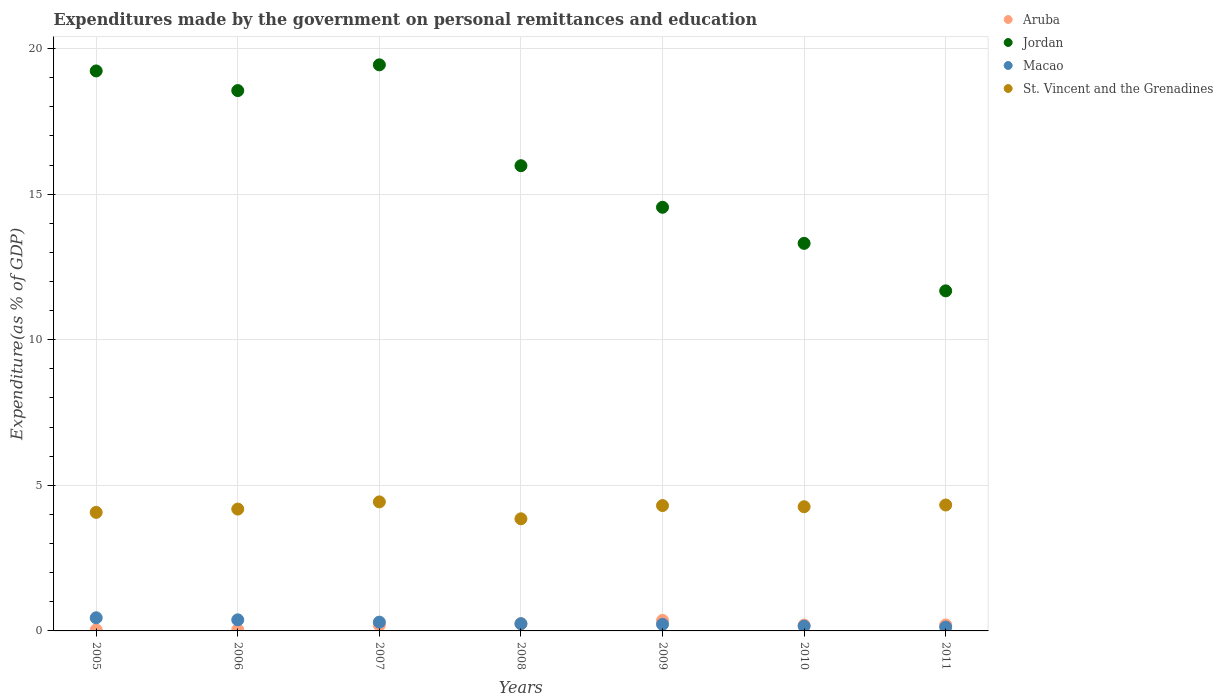How many different coloured dotlines are there?
Your response must be concise. 4. What is the expenditures made by the government on personal remittances and education in Jordan in 2009?
Ensure brevity in your answer.  14.55. Across all years, what is the maximum expenditures made by the government on personal remittances and education in St. Vincent and the Grenadines?
Provide a short and direct response. 4.43. Across all years, what is the minimum expenditures made by the government on personal remittances and education in Aruba?
Keep it short and to the point. 0.04. In which year was the expenditures made by the government on personal remittances and education in St. Vincent and the Grenadines minimum?
Offer a terse response. 2008. What is the total expenditures made by the government on personal remittances and education in Macao in the graph?
Make the answer very short. 1.91. What is the difference between the expenditures made by the government on personal remittances and education in St. Vincent and the Grenadines in 2007 and that in 2010?
Offer a terse response. 0.17. What is the difference between the expenditures made by the government on personal remittances and education in St. Vincent and the Grenadines in 2006 and the expenditures made by the government on personal remittances and education in Jordan in 2005?
Provide a succinct answer. -15.05. What is the average expenditures made by the government on personal remittances and education in Aruba per year?
Ensure brevity in your answer.  0.18. In the year 2009, what is the difference between the expenditures made by the government on personal remittances and education in Aruba and expenditures made by the government on personal remittances and education in Jordan?
Keep it short and to the point. -14.19. What is the ratio of the expenditures made by the government on personal remittances and education in Macao in 2007 to that in 2009?
Give a very brief answer. 1.33. Is the expenditures made by the government on personal remittances and education in Jordan in 2006 less than that in 2008?
Your response must be concise. No. What is the difference between the highest and the second highest expenditures made by the government on personal remittances and education in Macao?
Provide a short and direct response. 0.07. What is the difference between the highest and the lowest expenditures made by the government on personal remittances and education in Macao?
Your answer should be compact. 0.32. In how many years, is the expenditures made by the government on personal remittances and education in Macao greater than the average expenditures made by the government on personal remittances and education in Macao taken over all years?
Ensure brevity in your answer.  3. Is the sum of the expenditures made by the government on personal remittances and education in Jordan in 2005 and 2010 greater than the maximum expenditures made by the government on personal remittances and education in St. Vincent and the Grenadines across all years?
Your response must be concise. Yes. How many dotlines are there?
Ensure brevity in your answer.  4. How many years are there in the graph?
Offer a terse response. 7. Does the graph contain any zero values?
Ensure brevity in your answer.  No. Where does the legend appear in the graph?
Keep it short and to the point. Top right. How many legend labels are there?
Offer a terse response. 4. How are the legend labels stacked?
Your answer should be very brief. Vertical. What is the title of the graph?
Provide a succinct answer. Expenditures made by the government on personal remittances and education. What is the label or title of the Y-axis?
Give a very brief answer. Expenditure(as % of GDP). What is the Expenditure(as % of GDP) in Aruba in 2005?
Make the answer very short. 0.04. What is the Expenditure(as % of GDP) in Jordan in 2005?
Your answer should be very brief. 19.23. What is the Expenditure(as % of GDP) of Macao in 2005?
Your answer should be compact. 0.45. What is the Expenditure(as % of GDP) in St. Vincent and the Grenadines in 2005?
Give a very brief answer. 4.07. What is the Expenditure(as % of GDP) of Aruba in 2006?
Ensure brevity in your answer.  0.04. What is the Expenditure(as % of GDP) of Jordan in 2006?
Your response must be concise. 18.56. What is the Expenditure(as % of GDP) in Macao in 2006?
Offer a terse response. 0.38. What is the Expenditure(as % of GDP) of St. Vincent and the Grenadines in 2006?
Your answer should be very brief. 4.18. What is the Expenditure(as % of GDP) of Aruba in 2007?
Your answer should be compact. 0.2. What is the Expenditure(as % of GDP) in Jordan in 2007?
Ensure brevity in your answer.  19.44. What is the Expenditure(as % of GDP) of Macao in 2007?
Give a very brief answer. 0.3. What is the Expenditure(as % of GDP) of St. Vincent and the Grenadines in 2007?
Your response must be concise. 4.43. What is the Expenditure(as % of GDP) of Aruba in 2008?
Provide a short and direct response. 0.24. What is the Expenditure(as % of GDP) of Jordan in 2008?
Provide a succinct answer. 15.98. What is the Expenditure(as % of GDP) in Macao in 2008?
Your answer should be compact. 0.25. What is the Expenditure(as % of GDP) in St. Vincent and the Grenadines in 2008?
Offer a very short reply. 3.85. What is the Expenditure(as % of GDP) of Aruba in 2009?
Keep it short and to the point. 0.36. What is the Expenditure(as % of GDP) of Jordan in 2009?
Offer a very short reply. 14.55. What is the Expenditure(as % of GDP) of Macao in 2009?
Give a very brief answer. 0.23. What is the Expenditure(as % of GDP) of St. Vincent and the Grenadines in 2009?
Your answer should be compact. 4.31. What is the Expenditure(as % of GDP) in Aruba in 2010?
Your response must be concise. 0.2. What is the Expenditure(as % of GDP) of Jordan in 2010?
Your answer should be compact. 13.31. What is the Expenditure(as % of GDP) of Macao in 2010?
Your answer should be compact. 0.17. What is the Expenditure(as % of GDP) in St. Vincent and the Grenadines in 2010?
Make the answer very short. 4.27. What is the Expenditure(as % of GDP) in Aruba in 2011?
Your answer should be compact. 0.21. What is the Expenditure(as % of GDP) in Jordan in 2011?
Make the answer very short. 11.68. What is the Expenditure(as % of GDP) of Macao in 2011?
Your answer should be very brief. 0.13. What is the Expenditure(as % of GDP) of St. Vincent and the Grenadines in 2011?
Provide a succinct answer. 4.32. Across all years, what is the maximum Expenditure(as % of GDP) in Aruba?
Offer a very short reply. 0.36. Across all years, what is the maximum Expenditure(as % of GDP) of Jordan?
Your response must be concise. 19.44. Across all years, what is the maximum Expenditure(as % of GDP) of Macao?
Keep it short and to the point. 0.45. Across all years, what is the maximum Expenditure(as % of GDP) in St. Vincent and the Grenadines?
Your answer should be compact. 4.43. Across all years, what is the minimum Expenditure(as % of GDP) in Aruba?
Your response must be concise. 0.04. Across all years, what is the minimum Expenditure(as % of GDP) in Jordan?
Your response must be concise. 11.68. Across all years, what is the minimum Expenditure(as % of GDP) in Macao?
Your response must be concise. 0.13. Across all years, what is the minimum Expenditure(as % of GDP) of St. Vincent and the Grenadines?
Offer a terse response. 3.85. What is the total Expenditure(as % of GDP) of Aruba in the graph?
Keep it short and to the point. 1.29. What is the total Expenditure(as % of GDP) of Jordan in the graph?
Keep it short and to the point. 112.74. What is the total Expenditure(as % of GDP) in Macao in the graph?
Give a very brief answer. 1.91. What is the total Expenditure(as % of GDP) of St. Vincent and the Grenadines in the graph?
Ensure brevity in your answer.  29.43. What is the difference between the Expenditure(as % of GDP) in Aruba in 2005 and that in 2006?
Provide a short and direct response. -0.01. What is the difference between the Expenditure(as % of GDP) of Jordan in 2005 and that in 2006?
Offer a very short reply. 0.67. What is the difference between the Expenditure(as % of GDP) in Macao in 2005 and that in 2006?
Give a very brief answer. 0.07. What is the difference between the Expenditure(as % of GDP) in St. Vincent and the Grenadines in 2005 and that in 2006?
Make the answer very short. -0.11. What is the difference between the Expenditure(as % of GDP) of Aruba in 2005 and that in 2007?
Provide a short and direct response. -0.16. What is the difference between the Expenditure(as % of GDP) of Jordan in 2005 and that in 2007?
Your answer should be compact. -0.21. What is the difference between the Expenditure(as % of GDP) of Macao in 2005 and that in 2007?
Make the answer very short. 0.15. What is the difference between the Expenditure(as % of GDP) of St. Vincent and the Grenadines in 2005 and that in 2007?
Give a very brief answer. -0.36. What is the difference between the Expenditure(as % of GDP) in Aruba in 2005 and that in 2008?
Your response must be concise. -0.21. What is the difference between the Expenditure(as % of GDP) in Jordan in 2005 and that in 2008?
Your answer should be very brief. 3.25. What is the difference between the Expenditure(as % of GDP) of Macao in 2005 and that in 2008?
Your answer should be compact. 0.2. What is the difference between the Expenditure(as % of GDP) in St. Vincent and the Grenadines in 2005 and that in 2008?
Ensure brevity in your answer.  0.22. What is the difference between the Expenditure(as % of GDP) in Aruba in 2005 and that in 2009?
Keep it short and to the point. -0.33. What is the difference between the Expenditure(as % of GDP) in Jordan in 2005 and that in 2009?
Your answer should be very brief. 4.68. What is the difference between the Expenditure(as % of GDP) in Macao in 2005 and that in 2009?
Provide a succinct answer. 0.22. What is the difference between the Expenditure(as % of GDP) in St. Vincent and the Grenadines in 2005 and that in 2009?
Your answer should be very brief. -0.23. What is the difference between the Expenditure(as % of GDP) in Aruba in 2005 and that in 2010?
Give a very brief answer. -0.17. What is the difference between the Expenditure(as % of GDP) in Jordan in 2005 and that in 2010?
Make the answer very short. 5.92. What is the difference between the Expenditure(as % of GDP) in Macao in 2005 and that in 2010?
Offer a terse response. 0.29. What is the difference between the Expenditure(as % of GDP) in St. Vincent and the Grenadines in 2005 and that in 2010?
Offer a terse response. -0.19. What is the difference between the Expenditure(as % of GDP) in Aruba in 2005 and that in 2011?
Your answer should be very brief. -0.17. What is the difference between the Expenditure(as % of GDP) of Jordan in 2005 and that in 2011?
Make the answer very short. 7.55. What is the difference between the Expenditure(as % of GDP) of Macao in 2005 and that in 2011?
Your answer should be very brief. 0.32. What is the difference between the Expenditure(as % of GDP) in St. Vincent and the Grenadines in 2005 and that in 2011?
Offer a terse response. -0.25. What is the difference between the Expenditure(as % of GDP) in Aruba in 2006 and that in 2007?
Give a very brief answer. -0.16. What is the difference between the Expenditure(as % of GDP) in Jordan in 2006 and that in 2007?
Your response must be concise. -0.88. What is the difference between the Expenditure(as % of GDP) in Macao in 2006 and that in 2007?
Your answer should be very brief. 0.08. What is the difference between the Expenditure(as % of GDP) in St. Vincent and the Grenadines in 2006 and that in 2007?
Provide a short and direct response. -0.25. What is the difference between the Expenditure(as % of GDP) in Aruba in 2006 and that in 2008?
Keep it short and to the point. -0.2. What is the difference between the Expenditure(as % of GDP) in Jordan in 2006 and that in 2008?
Provide a short and direct response. 2.58. What is the difference between the Expenditure(as % of GDP) of Macao in 2006 and that in 2008?
Offer a very short reply. 0.13. What is the difference between the Expenditure(as % of GDP) of St. Vincent and the Grenadines in 2006 and that in 2008?
Your response must be concise. 0.33. What is the difference between the Expenditure(as % of GDP) of Aruba in 2006 and that in 2009?
Offer a terse response. -0.32. What is the difference between the Expenditure(as % of GDP) in Jordan in 2006 and that in 2009?
Your answer should be compact. 4.01. What is the difference between the Expenditure(as % of GDP) in Macao in 2006 and that in 2009?
Your answer should be very brief. 0.15. What is the difference between the Expenditure(as % of GDP) of St. Vincent and the Grenadines in 2006 and that in 2009?
Offer a terse response. -0.12. What is the difference between the Expenditure(as % of GDP) of Aruba in 2006 and that in 2010?
Make the answer very short. -0.16. What is the difference between the Expenditure(as % of GDP) of Jordan in 2006 and that in 2010?
Make the answer very short. 5.25. What is the difference between the Expenditure(as % of GDP) in Macao in 2006 and that in 2010?
Give a very brief answer. 0.22. What is the difference between the Expenditure(as % of GDP) of St. Vincent and the Grenadines in 2006 and that in 2010?
Provide a short and direct response. -0.08. What is the difference between the Expenditure(as % of GDP) in Aruba in 2006 and that in 2011?
Offer a very short reply. -0.16. What is the difference between the Expenditure(as % of GDP) of Jordan in 2006 and that in 2011?
Offer a terse response. 6.88. What is the difference between the Expenditure(as % of GDP) of Macao in 2006 and that in 2011?
Provide a succinct answer. 0.25. What is the difference between the Expenditure(as % of GDP) in St. Vincent and the Grenadines in 2006 and that in 2011?
Ensure brevity in your answer.  -0.14. What is the difference between the Expenditure(as % of GDP) in Aruba in 2007 and that in 2008?
Offer a terse response. -0.04. What is the difference between the Expenditure(as % of GDP) of Jordan in 2007 and that in 2008?
Offer a terse response. 3.46. What is the difference between the Expenditure(as % of GDP) of Macao in 2007 and that in 2008?
Keep it short and to the point. 0.05. What is the difference between the Expenditure(as % of GDP) in St. Vincent and the Grenadines in 2007 and that in 2008?
Provide a short and direct response. 0.58. What is the difference between the Expenditure(as % of GDP) of Aruba in 2007 and that in 2009?
Keep it short and to the point. -0.16. What is the difference between the Expenditure(as % of GDP) in Jordan in 2007 and that in 2009?
Keep it short and to the point. 4.89. What is the difference between the Expenditure(as % of GDP) in Macao in 2007 and that in 2009?
Provide a short and direct response. 0.07. What is the difference between the Expenditure(as % of GDP) of St. Vincent and the Grenadines in 2007 and that in 2009?
Your answer should be very brief. 0.13. What is the difference between the Expenditure(as % of GDP) in Aruba in 2007 and that in 2010?
Your answer should be compact. -0. What is the difference between the Expenditure(as % of GDP) of Jordan in 2007 and that in 2010?
Ensure brevity in your answer.  6.13. What is the difference between the Expenditure(as % of GDP) of Macao in 2007 and that in 2010?
Provide a short and direct response. 0.14. What is the difference between the Expenditure(as % of GDP) in St. Vincent and the Grenadines in 2007 and that in 2010?
Your response must be concise. 0.17. What is the difference between the Expenditure(as % of GDP) of Aruba in 2007 and that in 2011?
Your answer should be compact. -0.01. What is the difference between the Expenditure(as % of GDP) of Jordan in 2007 and that in 2011?
Provide a short and direct response. 7.76. What is the difference between the Expenditure(as % of GDP) in Macao in 2007 and that in 2011?
Offer a terse response. 0.17. What is the difference between the Expenditure(as % of GDP) in St. Vincent and the Grenadines in 2007 and that in 2011?
Provide a succinct answer. 0.11. What is the difference between the Expenditure(as % of GDP) of Aruba in 2008 and that in 2009?
Offer a terse response. -0.12. What is the difference between the Expenditure(as % of GDP) of Jordan in 2008 and that in 2009?
Provide a succinct answer. 1.43. What is the difference between the Expenditure(as % of GDP) in Macao in 2008 and that in 2009?
Provide a short and direct response. 0.02. What is the difference between the Expenditure(as % of GDP) of St. Vincent and the Grenadines in 2008 and that in 2009?
Your answer should be compact. -0.45. What is the difference between the Expenditure(as % of GDP) in Aruba in 2008 and that in 2010?
Provide a short and direct response. 0.04. What is the difference between the Expenditure(as % of GDP) of Jordan in 2008 and that in 2010?
Give a very brief answer. 2.67. What is the difference between the Expenditure(as % of GDP) of Macao in 2008 and that in 2010?
Your response must be concise. 0.08. What is the difference between the Expenditure(as % of GDP) in St. Vincent and the Grenadines in 2008 and that in 2010?
Your answer should be compact. -0.41. What is the difference between the Expenditure(as % of GDP) in Aruba in 2008 and that in 2011?
Provide a short and direct response. 0.04. What is the difference between the Expenditure(as % of GDP) of Jordan in 2008 and that in 2011?
Your response must be concise. 4.3. What is the difference between the Expenditure(as % of GDP) in Macao in 2008 and that in 2011?
Your answer should be compact. 0.12. What is the difference between the Expenditure(as % of GDP) of St. Vincent and the Grenadines in 2008 and that in 2011?
Make the answer very short. -0.47. What is the difference between the Expenditure(as % of GDP) of Aruba in 2009 and that in 2010?
Your response must be concise. 0.16. What is the difference between the Expenditure(as % of GDP) in Jordan in 2009 and that in 2010?
Give a very brief answer. 1.24. What is the difference between the Expenditure(as % of GDP) of Macao in 2009 and that in 2010?
Offer a terse response. 0.06. What is the difference between the Expenditure(as % of GDP) of St. Vincent and the Grenadines in 2009 and that in 2010?
Your answer should be very brief. 0.04. What is the difference between the Expenditure(as % of GDP) of Aruba in 2009 and that in 2011?
Your answer should be very brief. 0.16. What is the difference between the Expenditure(as % of GDP) of Jordan in 2009 and that in 2011?
Your response must be concise. 2.87. What is the difference between the Expenditure(as % of GDP) of Macao in 2009 and that in 2011?
Your answer should be very brief. 0.1. What is the difference between the Expenditure(as % of GDP) of St. Vincent and the Grenadines in 2009 and that in 2011?
Your answer should be compact. -0.02. What is the difference between the Expenditure(as % of GDP) in Aruba in 2010 and that in 2011?
Give a very brief answer. -0. What is the difference between the Expenditure(as % of GDP) of Jordan in 2010 and that in 2011?
Offer a terse response. 1.63. What is the difference between the Expenditure(as % of GDP) of Macao in 2010 and that in 2011?
Your answer should be very brief. 0.03. What is the difference between the Expenditure(as % of GDP) of St. Vincent and the Grenadines in 2010 and that in 2011?
Offer a very short reply. -0.06. What is the difference between the Expenditure(as % of GDP) in Aruba in 2005 and the Expenditure(as % of GDP) in Jordan in 2006?
Provide a succinct answer. -18.52. What is the difference between the Expenditure(as % of GDP) of Aruba in 2005 and the Expenditure(as % of GDP) of Macao in 2006?
Your answer should be very brief. -0.35. What is the difference between the Expenditure(as % of GDP) in Aruba in 2005 and the Expenditure(as % of GDP) in St. Vincent and the Grenadines in 2006?
Your answer should be compact. -4.15. What is the difference between the Expenditure(as % of GDP) in Jordan in 2005 and the Expenditure(as % of GDP) in Macao in 2006?
Provide a short and direct response. 18.85. What is the difference between the Expenditure(as % of GDP) in Jordan in 2005 and the Expenditure(as % of GDP) in St. Vincent and the Grenadines in 2006?
Your answer should be very brief. 15.05. What is the difference between the Expenditure(as % of GDP) in Macao in 2005 and the Expenditure(as % of GDP) in St. Vincent and the Grenadines in 2006?
Make the answer very short. -3.73. What is the difference between the Expenditure(as % of GDP) of Aruba in 2005 and the Expenditure(as % of GDP) of Jordan in 2007?
Provide a short and direct response. -19.41. What is the difference between the Expenditure(as % of GDP) in Aruba in 2005 and the Expenditure(as % of GDP) in Macao in 2007?
Your answer should be compact. -0.27. What is the difference between the Expenditure(as % of GDP) in Aruba in 2005 and the Expenditure(as % of GDP) in St. Vincent and the Grenadines in 2007?
Ensure brevity in your answer.  -4.4. What is the difference between the Expenditure(as % of GDP) in Jordan in 2005 and the Expenditure(as % of GDP) in Macao in 2007?
Make the answer very short. 18.93. What is the difference between the Expenditure(as % of GDP) of Jordan in 2005 and the Expenditure(as % of GDP) of St. Vincent and the Grenadines in 2007?
Provide a succinct answer. 14.8. What is the difference between the Expenditure(as % of GDP) in Macao in 2005 and the Expenditure(as % of GDP) in St. Vincent and the Grenadines in 2007?
Keep it short and to the point. -3.98. What is the difference between the Expenditure(as % of GDP) in Aruba in 2005 and the Expenditure(as % of GDP) in Jordan in 2008?
Your answer should be very brief. -15.94. What is the difference between the Expenditure(as % of GDP) in Aruba in 2005 and the Expenditure(as % of GDP) in Macao in 2008?
Provide a short and direct response. -0.21. What is the difference between the Expenditure(as % of GDP) in Aruba in 2005 and the Expenditure(as % of GDP) in St. Vincent and the Grenadines in 2008?
Make the answer very short. -3.82. What is the difference between the Expenditure(as % of GDP) of Jordan in 2005 and the Expenditure(as % of GDP) of Macao in 2008?
Provide a succinct answer. 18.98. What is the difference between the Expenditure(as % of GDP) in Jordan in 2005 and the Expenditure(as % of GDP) in St. Vincent and the Grenadines in 2008?
Your response must be concise. 15.38. What is the difference between the Expenditure(as % of GDP) of Macao in 2005 and the Expenditure(as % of GDP) of St. Vincent and the Grenadines in 2008?
Offer a terse response. -3.4. What is the difference between the Expenditure(as % of GDP) in Aruba in 2005 and the Expenditure(as % of GDP) in Jordan in 2009?
Keep it short and to the point. -14.51. What is the difference between the Expenditure(as % of GDP) in Aruba in 2005 and the Expenditure(as % of GDP) in Macao in 2009?
Keep it short and to the point. -0.19. What is the difference between the Expenditure(as % of GDP) in Aruba in 2005 and the Expenditure(as % of GDP) in St. Vincent and the Grenadines in 2009?
Provide a succinct answer. -4.27. What is the difference between the Expenditure(as % of GDP) of Jordan in 2005 and the Expenditure(as % of GDP) of Macao in 2009?
Your answer should be very brief. 19. What is the difference between the Expenditure(as % of GDP) in Jordan in 2005 and the Expenditure(as % of GDP) in St. Vincent and the Grenadines in 2009?
Your answer should be very brief. 14.93. What is the difference between the Expenditure(as % of GDP) of Macao in 2005 and the Expenditure(as % of GDP) of St. Vincent and the Grenadines in 2009?
Your response must be concise. -3.85. What is the difference between the Expenditure(as % of GDP) in Aruba in 2005 and the Expenditure(as % of GDP) in Jordan in 2010?
Keep it short and to the point. -13.27. What is the difference between the Expenditure(as % of GDP) of Aruba in 2005 and the Expenditure(as % of GDP) of Macao in 2010?
Ensure brevity in your answer.  -0.13. What is the difference between the Expenditure(as % of GDP) in Aruba in 2005 and the Expenditure(as % of GDP) in St. Vincent and the Grenadines in 2010?
Ensure brevity in your answer.  -4.23. What is the difference between the Expenditure(as % of GDP) of Jordan in 2005 and the Expenditure(as % of GDP) of Macao in 2010?
Make the answer very short. 19.07. What is the difference between the Expenditure(as % of GDP) in Jordan in 2005 and the Expenditure(as % of GDP) in St. Vincent and the Grenadines in 2010?
Offer a terse response. 14.97. What is the difference between the Expenditure(as % of GDP) of Macao in 2005 and the Expenditure(as % of GDP) of St. Vincent and the Grenadines in 2010?
Your answer should be very brief. -3.81. What is the difference between the Expenditure(as % of GDP) in Aruba in 2005 and the Expenditure(as % of GDP) in Jordan in 2011?
Give a very brief answer. -11.64. What is the difference between the Expenditure(as % of GDP) of Aruba in 2005 and the Expenditure(as % of GDP) of Macao in 2011?
Provide a short and direct response. -0.1. What is the difference between the Expenditure(as % of GDP) of Aruba in 2005 and the Expenditure(as % of GDP) of St. Vincent and the Grenadines in 2011?
Offer a very short reply. -4.29. What is the difference between the Expenditure(as % of GDP) in Jordan in 2005 and the Expenditure(as % of GDP) in Macao in 2011?
Your answer should be compact. 19.1. What is the difference between the Expenditure(as % of GDP) of Jordan in 2005 and the Expenditure(as % of GDP) of St. Vincent and the Grenadines in 2011?
Your response must be concise. 14.91. What is the difference between the Expenditure(as % of GDP) of Macao in 2005 and the Expenditure(as % of GDP) of St. Vincent and the Grenadines in 2011?
Provide a succinct answer. -3.87. What is the difference between the Expenditure(as % of GDP) in Aruba in 2006 and the Expenditure(as % of GDP) in Jordan in 2007?
Your answer should be compact. -19.4. What is the difference between the Expenditure(as % of GDP) in Aruba in 2006 and the Expenditure(as % of GDP) in Macao in 2007?
Offer a terse response. -0.26. What is the difference between the Expenditure(as % of GDP) of Aruba in 2006 and the Expenditure(as % of GDP) of St. Vincent and the Grenadines in 2007?
Give a very brief answer. -4.39. What is the difference between the Expenditure(as % of GDP) in Jordan in 2006 and the Expenditure(as % of GDP) in Macao in 2007?
Make the answer very short. 18.25. What is the difference between the Expenditure(as % of GDP) of Jordan in 2006 and the Expenditure(as % of GDP) of St. Vincent and the Grenadines in 2007?
Provide a short and direct response. 14.12. What is the difference between the Expenditure(as % of GDP) in Macao in 2006 and the Expenditure(as % of GDP) in St. Vincent and the Grenadines in 2007?
Keep it short and to the point. -4.05. What is the difference between the Expenditure(as % of GDP) in Aruba in 2006 and the Expenditure(as % of GDP) in Jordan in 2008?
Offer a terse response. -15.93. What is the difference between the Expenditure(as % of GDP) of Aruba in 2006 and the Expenditure(as % of GDP) of Macao in 2008?
Offer a terse response. -0.21. What is the difference between the Expenditure(as % of GDP) of Aruba in 2006 and the Expenditure(as % of GDP) of St. Vincent and the Grenadines in 2008?
Offer a terse response. -3.81. What is the difference between the Expenditure(as % of GDP) in Jordan in 2006 and the Expenditure(as % of GDP) in Macao in 2008?
Provide a short and direct response. 18.31. What is the difference between the Expenditure(as % of GDP) in Jordan in 2006 and the Expenditure(as % of GDP) in St. Vincent and the Grenadines in 2008?
Provide a short and direct response. 14.71. What is the difference between the Expenditure(as % of GDP) in Macao in 2006 and the Expenditure(as % of GDP) in St. Vincent and the Grenadines in 2008?
Ensure brevity in your answer.  -3.47. What is the difference between the Expenditure(as % of GDP) of Aruba in 2006 and the Expenditure(as % of GDP) of Jordan in 2009?
Give a very brief answer. -14.51. What is the difference between the Expenditure(as % of GDP) of Aruba in 2006 and the Expenditure(as % of GDP) of Macao in 2009?
Provide a succinct answer. -0.18. What is the difference between the Expenditure(as % of GDP) in Aruba in 2006 and the Expenditure(as % of GDP) in St. Vincent and the Grenadines in 2009?
Provide a succinct answer. -4.26. What is the difference between the Expenditure(as % of GDP) of Jordan in 2006 and the Expenditure(as % of GDP) of Macao in 2009?
Keep it short and to the point. 18.33. What is the difference between the Expenditure(as % of GDP) of Jordan in 2006 and the Expenditure(as % of GDP) of St. Vincent and the Grenadines in 2009?
Keep it short and to the point. 14.25. What is the difference between the Expenditure(as % of GDP) of Macao in 2006 and the Expenditure(as % of GDP) of St. Vincent and the Grenadines in 2009?
Your answer should be compact. -3.92. What is the difference between the Expenditure(as % of GDP) of Aruba in 2006 and the Expenditure(as % of GDP) of Jordan in 2010?
Your response must be concise. -13.27. What is the difference between the Expenditure(as % of GDP) in Aruba in 2006 and the Expenditure(as % of GDP) in Macao in 2010?
Provide a succinct answer. -0.12. What is the difference between the Expenditure(as % of GDP) in Aruba in 2006 and the Expenditure(as % of GDP) in St. Vincent and the Grenadines in 2010?
Offer a terse response. -4.22. What is the difference between the Expenditure(as % of GDP) of Jordan in 2006 and the Expenditure(as % of GDP) of Macao in 2010?
Offer a very short reply. 18.39. What is the difference between the Expenditure(as % of GDP) in Jordan in 2006 and the Expenditure(as % of GDP) in St. Vincent and the Grenadines in 2010?
Your answer should be compact. 14.29. What is the difference between the Expenditure(as % of GDP) in Macao in 2006 and the Expenditure(as % of GDP) in St. Vincent and the Grenadines in 2010?
Provide a short and direct response. -3.88. What is the difference between the Expenditure(as % of GDP) in Aruba in 2006 and the Expenditure(as % of GDP) in Jordan in 2011?
Offer a very short reply. -11.64. What is the difference between the Expenditure(as % of GDP) in Aruba in 2006 and the Expenditure(as % of GDP) in Macao in 2011?
Your answer should be compact. -0.09. What is the difference between the Expenditure(as % of GDP) in Aruba in 2006 and the Expenditure(as % of GDP) in St. Vincent and the Grenadines in 2011?
Keep it short and to the point. -4.28. What is the difference between the Expenditure(as % of GDP) of Jordan in 2006 and the Expenditure(as % of GDP) of Macao in 2011?
Offer a very short reply. 18.42. What is the difference between the Expenditure(as % of GDP) in Jordan in 2006 and the Expenditure(as % of GDP) in St. Vincent and the Grenadines in 2011?
Your answer should be compact. 14.23. What is the difference between the Expenditure(as % of GDP) of Macao in 2006 and the Expenditure(as % of GDP) of St. Vincent and the Grenadines in 2011?
Your answer should be compact. -3.94. What is the difference between the Expenditure(as % of GDP) of Aruba in 2007 and the Expenditure(as % of GDP) of Jordan in 2008?
Offer a very short reply. -15.78. What is the difference between the Expenditure(as % of GDP) of Aruba in 2007 and the Expenditure(as % of GDP) of Macao in 2008?
Your answer should be very brief. -0.05. What is the difference between the Expenditure(as % of GDP) in Aruba in 2007 and the Expenditure(as % of GDP) in St. Vincent and the Grenadines in 2008?
Keep it short and to the point. -3.65. What is the difference between the Expenditure(as % of GDP) of Jordan in 2007 and the Expenditure(as % of GDP) of Macao in 2008?
Offer a very short reply. 19.19. What is the difference between the Expenditure(as % of GDP) of Jordan in 2007 and the Expenditure(as % of GDP) of St. Vincent and the Grenadines in 2008?
Give a very brief answer. 15.59. What is the difference between the Expenditure(as % of GDP) of Macao in 2007 and the Expenditure(as % of GDP) of St. Vincent and the Grenadines in 2008?
Ensure brevity in your answer.  -3.55. What is the difference between the Expenditure(as % of GDP) in Aruba in 2007 and the Expenditure(as % of GDP) in Jordan in 2009?
Give a very brief answer. -14.35. What is the difference between the Expenditure(as % of GDP) of Aruba in 2007 and the Expenditure(as % of GDP) of Macao in 2009?
Your answer should be very brief. -0.03. What is the difference between the Expenditure(as % of GDP) of Aruba in 2007 and the Expenditure(as % of GDP) of St. Vincent and the Grenadines in 2009?
Your answer should be compact. -4.11. What is the difference between the Expenditure(as % of GDP) in Jordan in 2007 and the Expenditure(as % of GDP) in Macao in 2009?
Your response must be concise. 19.21. What is the difference between the Expenditure(as % of GDP) of Jordan in 2007 and the Expenditure(as % of GDP) of St. Vincent and the Grenadines in 2009?
Your answer should be very brief. 15.14. What is the difference between the Expenditure(as % of GDP) in Macao in 2007 and the Expenditure(as % of GDP) in St. Vincent and the Grenadines in 2009?
Make the answer very short. -4. What is the difference between the Expenditure(as % of GDP) of Aruba in 2007 and the Expenditure(as % of GDP) of Jordan in 2010?
Make the answer very short. -13.11. What is the difference between the Expenditure(as % of GDP) of Aruba in 2007 and the Expenditure(as % of GDP) of Macao in 2010?
Provide a succinct answer. 0.03. What is the difference between the Expenditure(as % of GDP) of Aruba in 2007 and the Expenditure(as % of GDP) of St. Vincent and the Grenadines in 2010?
Your answer should be very brief. -4.07. What is the difference between the Expenditure(as % of GDP) in Jordan in 2007 and the Expenditure(as % of GDP) in Macao in 2010?
Offer a terse response. 19.28. What is the difference between the Expenditure(as % of GDP) in Jordan in 2007 and the Expenditure(as % of GDP) in St. Vincent and the Grenadines in 2010?
Give a very brief answer. 15.18. What is the difference between the Expenditure(as % of GDP) in Macao in 2007 and the Expenditure(as % of GDP) in St. Vincent and the Grenadines in 2010?
Your response must be concise. -3.96. What is the difference between the Expenditure(as % of GDP) in Aruba in 2007 and the Expenditure(as % of GDP) in Jordan in 2011?
Your answer should be compact. -11.48. What is the difference between the Expenditure(as % of GDP) in Aruba in 2007 and the Expenditure(as % of GDP) in Macao in 2011?
Provide a short and direct response. 0.07. What is the difference between the Expenditure(as % of GDP) of Aruba in 2007 and the Expenditure(as % of GDP) of St. Vincent and the Grenadines in 2011?
Your answer should be very brief. -4.13. What is the difference between the Expenditure(as % of GDP) of Jordan in 2007 and the Expenditure(as % of GDP) of Macao in 2011?
Provide a succinct answer. 19.31. What is the difference between the Expenditure(as % of GDP) in Jordan in 2007 and the Expenditure(as % of GDP) in St. Vincent and the Grenadines in 2011?
Give a very brief answer. 15.12. What is the difference between the Expenditure(as % of GDP) in Macao in 2007 and the Expenditure(as % of GDP) in St. Vincent and the Grenadines in 2011?
Ensure brevity in your answer.  -4.02. What is the difference between the Expenditure(as % of GDP) of Aruba in 2008 and the Expenditure(as % of GDP) of Jordan in 2009?
Your response must be concise. -14.31. What is the difference between the Expenditure(as % of GDP) in Aruba in 2008 and the Expenditure(as % of GDP) in Macao in 2009?
Keep it short and to the point. 0.02. What is the difference between the Expenditure(as % of GDP) of Aruba in 2008 and the Expenditure(as % of GDP) of St. Vincent and the Grenadines in 2009?
Provide a short and direct response. -4.06. What is the difference between the Expenditure(as % of GDP) in Jordan in 2008 and the Expenditure(as % of GDP) in Macao in 2009?
Ensure brevity in your answer.  15.75. What is the difference between the Expenditure(as % of GDP) of Jordan in 2008 and the Expenditure(as % of GDP) of St. Vincent and the Grenadines in 2009?
Provide a short and direct response. 11.67. What is the difference between the Expenditure(as % of GDP) in Macao in 2008 and the Expenditure(as % of GDP) in St. Vincent and the Grenadines in 2009?
Your answer should be compact. -4.06. What is the difference between the Expenditure(as % of GDP) of Aruba in 2008 and the Expenditure(as % of GDP) of Jordan in 2010?
Provide a succinct answer. -13.07. What is the difference between the Expenditure(as % of GDP) of Aruba in 2008 and the Expenditure(as % of GDP) of Macao in 2010?
Offer a terse response. 0.08. What is the difference between the Expenditure(as % of GDP) of Aruba in 2008 and the Expenditure(as % of GDP) of St. Vincent and the Grenadines in 2010?
Offer a terse response. -4.02. What is the difference between the Expenditure(as % of GDP) in Jordan in 2008 and the Expenditure(as % of GDP) in Macao in 2010?
Your answer should be very brief. 15.81. What is the difference between the Expenditure(as % of GDP) in Jordan in 2008 and the Expenditure(as % of GDP) in St. Vincent and the Grenadines in 2010?
Keep it short and to the point. 11.71. What is the difference between the Expenditure(as % of GDP) of Macao in 2008 and the Expenditure(as % of GDP) of St. Vincent and the Grenadines in 2010?
Your response must be concise. -4.02. What is the difference between the Expenditure(as % of GDP) in Aruba in 2008 and the Expenditure(as % of GDP) in Jordan in 2011?
Your answer should be very brief. -11.44. What is the difference between the Expenditure(as % of GDP) in Aruba in 2008 and the Expenditure(as % of GDP) in Macao in 2011?
Make the answer very short. 0.11. What is the difference between the Expenditure(as % of GDP) of Aruba in 2008 and the Expenditure(as % of GDP) of St. Vincent and the Grenadines in 2011?
Keep it short and to the point. -4.08. What is the difference between the Expenditure(as % of GDP) in Jordan in 2008 and the Expenditure(as % of GDP) in Macao in 2011?
Offer a very short reply. 15.84. What is the difference between the Expenditure(as % of GDP) in Jordan in 2008 and the Expenditure(as % of GDP) in St. Vincent and the Grenadines in 2011?
Offer a terse response. 11.65. What is the difference between the Expenditure(as % of GDP) of Macao in 2008 and the Expenditure(as % of GDP) of St. Vincent and the Grenadines in 2011?
Provide a succinct answer. -4.08. What is the difference between the Expenditure(as % of GDP) of Aruba in 2009 and the Expenditure(as % of GDP) of Jordan in 2010?
Ensure brevity in your answer.  -12.95. What is the difference between the Expenditure(as % of GDP) in Aruba in 2009 and the Expenditure(as % of GDP) in Macao in 2010?
Make the answer very short. 0.2. What is the difference between the Expenditure(as % of GDP) of Aruba in 2009 and the Expenditure(as % of GDP) of St. Vincent and the Grenadines in 2010?
Ensure brevity in your answer.  -3.9. What is the difference between the Expenditure(as % of GDP) in Jordan in 2009 and the Expenditure(as % of GDP) in Macao in 2010?
Give a very brief answer. 14.38. What is the difference between the Expenditure(as % of GDP) of Jordan in 2009 and the Expenditure(as % of GDP) of St. Vincent and the Grenadines in 2010?
Make the answer very short. 10.28. What is the difference between the Expenditure(as % of GDP) of Macao in 2009 and the Expenditure(as % of GDP) of St. Vincent and the Grenadines in 2010?
Offer a very short reply. -4.04. What is the difference between the Expenditure(as % of GDP) of Aruba in 2009 and the Expenditure(as % of GDP) of Jordan in 2011?
Keep it short and to the point. -11.32. What is the difference between the Expenditure(as % of GDP) of Aruba in 2009 and the Expenditure(as % of GDP) of Macao in 2011?
Your answer should be compact. 0.23. What is the difference between the Expenditure(as % of GDP) of Aruba in 2009 and the Expenditure(as % of GDP) of St. Vincent and the Grenadines in 2011?
Give a very brief answer. -3.96. What is the difference between the Expenditure(as % of GDP) in Jordan in 2009 and the Expenditure(as % of GDP) in Macao in 2011?
Make the answer very short. 14.42. What is the difference between the Expenditure(as % of GDP) in Jordan in 2009 and the Expenditure(as % of GDP) in St. Vincent and the Grenadines in 2011?
Provide a short and direct response. 10.22. What is the difference between the Expenditure(as % of GDP) in Macao in 2009 and the Expenditure(as % of GDP) in St. Vincent and the Grenadines in 2011?
Give a very brief answer. -4.1. What is the difference between the Expenditure(as % of GDP) in Aruba in 2010 and the Expenditure(as % of GDP) in Jordan in 2011?
Your response must be concise. -11.48. What is the difference between the Expenditure(as % of GDP) in Aruba in 2010 and the Expenditure(as % of GDP) in Macao in 2011?
Provide a short and direct response. 0.07. What is the difference between the Expenditure(as % of GDP) in Aruba in 2010 and the Expenditure(as % of GDP) in St. Vincent and the Grenadines in 2011?
Your answer should be compact. -4.12. What is the difference between the Expenditure(as % of GDP) in Jordan in 2010 and the Expenditure(as % of GDP) in Macao in 2011?
Provide a succinct answer. 13.18. What is the difference between the Expenditure(as % of GDP) of Jordan in 2010 and the Expenditure(as % of GDP) of St. Vincent and the Grenadines in 2011?
Keep it short and to the point. 8.99. What is the difference between the Expenditure(as % of GDP) of Macao in 2010 and the Expenditure(as % of GDP) of St. Vincent and the Grenadines in 2011?
Offer a terse response. -4.16. What is the average Expenditure(as % of GDP) of Aruba per year?
Your answer should be very brief. 0.18. What is the average Expenditure(as % of GDP) of Jordan per year?
Give a very brief answer. 16.11. What is the average Expenditure(as % of GDP) of Macao per year?
Give a very brief answer. 0.27. What is the average Expenditure(as % of GDP) of St. Vincent and the Grenadines per year?
Ensure brevity in your answer.  4.2. In the year 2005, what is the difference between the Expenditure(as % of GDP) in Aruba and Expenditure(as % of GDP) in Jordan?
Give a very brief answer. -19.2. In the year 2005, what is the difference between the Expenditure(as % of GDP) of Aruba and Expenditure(as % of GDP) of Macao?
Your answer should be very brief. -0.42. In the year 2005, what is the difference between the Expenditure(as % of GDP) of Aruba and Expenditure(as % of GDP) of St. Vincent and the Grenadines?
Offer a very short reply. -4.04. In the year 2005, what is the difference between the Expenditure(as % of GDP) in Jordan and Expenditure(as % of GDP) in Macao?
Offer a terse response. 18.78. In the year 2005, what is the difference between the Expenditure(as % of GDP) of Jordan and Expenditure(as % of GDP) of St. Vincent and the Grenadines?
Offer a very short reply. 15.16. In the year 2005, what is the difference between the Expenditure(as % of GDP) in Macao and Expenditure(as % of GDP) in St. Vincent and the Grenadines?
Give a very brief answer. -3.62. In the year 2006, what is the difference between the Expenditure(as % of GDP) in Aruba and Expenditure(as % of GDP) in Jordan?
Provide a succinct answer. -18.51. In the year 2006, what is the difference between the Expenditure(as % of GDP) in Aruba and Expenditure(as % of GDP) in Macao?
Provide a short and direct response. -0.34. In the year 2006, what is the difference between the Expenditure(as % of GDP) of Aruba and Expenditure(as % of GDP) of St. Vincent and the Grenadines?
Make the answer very short. -4.14. In the year 2006, what is the difference between the Expenditure(as % of GDP) in Jordan and Expenditure(as % of GDP) in Macao?
Offer a very short reply. 18.18. In the year 2006, what is the difference between the Expenditure(as % of GDP) in Jordan and Expenditure(as % of GDP) in St. Vincent and the Grenadines?
Your response must be concise. 14.37. In the year 2006, what is the difference between the Expenditure(as % of GDP) of Macao and Expenditure(as % of GDP) of St. Vincent and the Grenadines?
Your answer should be compact. -3.8. In the year 2007, what is the difference between the Expenditure(as % of GDP) in Aruba and Expenditure(as % of GDP) in Jordan?
Your answer should be compact. -19.24. In the year 2007, what is the difference between the Expenditure(as % of GDP) of Aruba and Expenditure(as % of GDP) of Macao?
Your answer should be compact. -0.1. In the year 2007, what is the difference between the Expenditure(as % of GDP) of Aruba and Expenditure(as % of GDP) of St. Vincent and the Grenadines?
Keep it short and to the point. -4.23. In the year 2007, what is the difference between the Expenditure(as % of GDP) of Jordan and Expenditure(as % of GDP) of Macao?
Provide a short and direct response. 19.14. In the year 2007, what is the difference between the Expenditure(as % of GDP) in Jordan and Expenditure(as % of GDP) in St. Vincent and the Grenadines?
Provide a succinct answer. 15.01. In the year 2007, what is the difference between the Expenditure(as % of GDP) of Macao and Expenditure(as % of GDP) of St. Vincent and the Grenadines?
Provide a succinct answer. -4.13. In the year 2008, what is the difference between the Expenditure(as % of GDP) of Aruba and Expenditure(as % of GDP) of Jordan?
Keep it short and to the point. -15.73. In the year 2008, what is the difference between the Expenditure(as % of GDP) in Aruba and Expenditure(as % of GDP) in Macao?
Your answer should be very brief. -0.01. In the year 2008, what is the difference between the Expenditure(as % of GDP) in Aruba and Expenditure(as % of GDP) in St. Vincent and the Grenadines?
Offer a terse response. -3.61. In the year 2008, what is the difference between the Expenditure(as % of GDP) in Jordan and Expenditure(as % of GDP) in Macao?
Your answer should be very brief. 15.73. In the year 2008, what is the difference between the Expenditure(as % of GDP) of Jordan and Expenditure(as % of GDP) of St. Vincent and the Grenadines?
Give a very brief answer. 12.13. In the year 2008, what is the difference between the Expenditure(as % of GDP) in Macao and Expenditure(as % of GDP) in St. Vincent and the Grenadines?
Offer a very short reply. -3.6. In the year 2009, what is the difference between the Expenditure(as % of GDP) in Aruba and Expenditure(as % of GDP) in Jordan?
Your response must be concise. -14.19. In the year 2009, what is the difference between the Expenditure(as % of GDP) of Aruba and Expenditure(as % of GDP) of Macao?
Keep it short and to the point. 0.14. In the year 2009, what is the difference between the Expenditure(as % of GDP) in Aruba and Expenditure(as % of GDP) in St. Vincent and the Grenadines?
Your response must be concise. -3.94. In the year 2009, what is the difference between the Expenditure(as % of GDP) of Jordan and Expenditure(as % of GDP) of Macao?
Offer a terse response. 14.32. In the year 2009, what is the difference between the Expenditure(as % of GDP) in Jordan and Expenditure(as % of GDP) in St. Vincent and the Grenadines?
Offer a terse response. 10.24. In the year 2009, what is the difference between the Expenditure(as % of GDP) of Macao and Expenditure(as % of GDP) of St. Vincent and the Grenadines?
Offer a very short reply. -4.08. In the year 2010, what is the difference between the Expenditure(as % of GDP) in Aruba and Expenditure(as % of GDP) in Jordan?
Provide a succinct answer. -13.11. In the year 2010, what is the difference between the Expenditure(as % of GDP) of Aruba and Expenditure(as % of GDP) of Macao?
Provide a short and direct response. 0.04. In the year 2010, what is the difference between the Expenditure(as % of GDP) of Aruba and Expenditure(as % of GDP) of St. Vincent and the Grenadines?
Ensure brevity in your answer.  -4.06. In the year 2010, what is the difference between the Expenditure(as % of GDP) in Jordan and Expenditure(as % of GDP) in Macao?
Your answer should be very brief. 13.14. In the year 2010, what is the difference between the Expenditure(as % of GDP) of Jordan and Expenditure(as % of GDP) of St. Vincent and the Grenadines?
Offer a terse response. 9.04. In the year 2010, what is the difference between the Expenditure(as % of GDP) in Macao and Expenditure(as % of GDP) in St. Vincent and the Grenadines?
Your response must be concise. -4.1. In the year 2011, what is the difference between the Expenditure(as % of GDP) of Aruba and Expenditure(as % of GDP) of Jordan?
Keep it short and to the point. -11.47. In the year 2011, what is the difference between the Expenditure(as % of GDP) of Aruba and Expenditure(as % of GDP) of Macao?
Make the answer very short. 0.07. In the year 2011, what is the difference between the Expenditure(as % of GDP) of Aruba and Expenditure(as % of GDP) of St. Vincent and the Grenadines?
Ensure brevity in your answer.  -4.12. In the year 2011, what is the difference between the Expenditure(as % of GDP) in Jordan and Expenditure(as % of GDP) in Macao?
Your answer should be very brief. 11.55. In the year 2011, what is the difference between the Expenditure(as % of GDP) in Jordan and Expenditure(as % of GDP) in St. Vincent and the Grenadines?
Offer a terse response. 7.35. In the year 2011, what is the difference between the Expenditure(as % of GDP) of Macao and Expenditure(as % of GDP) of St. Vincent and the Grenadines?
Your answer should be very brief. -4.19. What is the ratio of the Expenditure(as % of GDP) in Aruba in 2005 to that in 2006?
Your response must be concise. 0.82. What is the ratio of the Expenditure(as % of GDP) in Jordan in 2005 to that in 2006?
Your answer should be compact. 1.04. What is the ratio of the Expenditure(as % of GDP) of Macao in 2005 to that in 2006?
Provide a succinct answer. 1.18. What is the ratio of the Expenditure(as % of GDP) in St. Vincent and the Grenadines in 2005 to that in 2006?
Ensure brevity in your answer.  0.97. What is the ratio of the Expenditure(as % of GDP) in Aruba in 2005 to that in 2007?
Provide a succinct answer. 0.18. What is the ratio of the Expenditure(as % of GDP) in Jordan in 2005 to that in 2007?
Provide a short and direct response. 0.99. What is the ratio of the Expenditure(as % of GDP) in Macao in 2005 to that in 2007?
Your answer should be very brief. 1.5. What is the ratio of the Expenditure(as % of GDP) in St. Vincent and the Grenadines in 2005 to that in 2007?
Make the answer very short. 0.92. What is the ratio of the Expenditure(as % of GDP) of Aruba in 2005 to that in 2008?
Keep it short and to the point. 0.15. What is the ratio of the Expenditure(as % of GDP) of Jordan in 2005 to that in 2008?
Give a very brief answer. 1.2. What is the ratio of the Expenditure(as % of GDP) in Macao in 2005 to that in 2008?
Make the answer very short. 1.81. What is the ratio of the Expenditure(as % of GDP) of St. Vincent and the Grenadines in 2005 to that in 2008?
Keep it short and to the point. 1.06. What is the ratio of the Expenditure(as % of GDP) in Aruba in 2005 to that in 2009?
Your answer should be compact. 0.1. What is the ratio of the Expenditure(as % of GDP) of Jordan in 2005 to that in 2009?
Provide a short and direct response. 1.32. What is the ratio of the Expenditure(as % of GDP) of Macao in 2005 to that in 2009?
Your answer should be compact. 1.99. What is the ratio of the Expenditure(as % of GDP) of St. Vincent and the Grenadines in 2005 to that in 2009?
Offer a very short reply. 0.95. What is the ratio of the Expenditure(as % of GDP) in Aruba in 2005 to that in 2010?
Offer a terse response. 0.17. What is the ratio of the Expenditure(as % of GDP) in Jordan in 2005 to that in 2010?
Keep it short and to the point. 1.44. What is the ratio of the Expenditure(as % of GDP) of Macao in 2005 to that in 2010?
Ensure brevity in your answer.  2.73. What is the ratio of the Expenditure(as % of GDP) in St. Vincent and the Grenadines in 2005 to that in 2010?
Provide a succinct answer. 0.95. What is the ratio of the Expenditure(as % of GDP) in Aruba in 2005 to that in 2011?
Your response must be concise. 0.17. What is the ratio of the Expenditure(as % of GDP) of Jordan in 2005 to that in 2011?
Provide a short and direct response. 1.65. What is the ratio of the Expenditure(as % of GDP) of Macao in 2005 to that in 2011?
Make the answer very short. 3.42. What is the ratio of the Expenditure(as % of GDP) in St. Vincent and the Grenadines in 2005 to that in 2011?
Your answer should be compact. 0.94. What is the ratio of the Expenditure(as % of GDP) in Aruba in 2006 to that in 2007?
Your answer should be very brief. 0.22. What is the ratio of the Expenditure(as % of GDP) of Jordan in 2006 to that in 2007?
Your answer should be very brief. 0.95. What is the ratio of the Expenditure(as % of GDP) in Macao in 2006 to that in 2007?
Your response must be concise. 1.26. What is the ratio of the Expenditure(as % of GDP) in St. Vincent and the Grenadines in 2006 to that in 2007?
Provide a succinct answer. 0.94. What is the ratio of the Expenditure(as % of GDP) in Aruba in 2006 to that in 2008?
Offer a terse response. 0.18. What is the ratio of the Expenditure(as % of GDP) in Jordan in 2006 to that in 2008?
Your response must be concise. 1.16. What is the ratio of the Expenditure(as % of GDP) of Macao in 2006 to that in 2008?
Ensure brevity in your answer.  1.53. What is the ratio of the Expenditure(as % of GDP) of St. Vincent and the Grenadines in 2006 to that in 2008?
Offer a terse response. 1.09. What is the ratio of the Expenditure(as % of GDP) of Aruba in 2006 to that in 2009?
Offer a very short reply. 0.12. What is the ratio of the Expenditure(as % of GDP) of Jordan in 2006 to that in 2009?
Give a very brief answer. 1.28. What is the ratio of the Expenditure(as % of GDP) of Macao in 2006 to that in 2009?
Your answer should be very brief. 1.68. What is the ratio of the Expenditure(as % of GDP) of St. Vincent and the Grenadines in 2006 to that in 2009?
Your answer should be compact. 0.97. What is the ratio of the Expenditure(as % of GDP) in Aruba in 2006 to that in 2010?
Give a very brief answer. 0.21. What is the ratio of the Expenditure(as % of GDP) in Jordan in 2006 to that in 2010?
Ensure brevity in your answer.  1.39. What is the ratio of the Expenditure(as % of GDP) of Macao in 2006 to that in 2010?
Provide a succinct answer. 2.3. What is the ratio of the Expenditure(as % of GDP) of St. Vincent and the Grenadines in 2006 to that in 2010?
Keep it short and to the point. 0.98. What is the ratio of the Expenditure(as % of GDP) of Aruba in 2006 to that in 2011?
Your answer should be very brief. 0.21. What is the ratio of the Expenditure(as % of GDP) in Jordan in 2006 to that in 2011?
Ensure brevity in your answer.  1.59. What is the ratio of the Expenditure(as % of GDP) of Macao in 2006 to that in 2011?
Keep it short and to the point. 2.89. What is the ratio of the Expenditure(as % of GDP) in Aruba in 2007 to that in 2008?
Provide a short and direct response. 0.82. What is the ratio of the Expenditure(as % of GDP) of Jordan in 2007 to that in 2008?
Offer a terse response. 1.22. What is the ratio of the Expenditure(as % of GDP) of Macao in 2007 to that in 2008?
Give a very brief answer. 1.21. What is the ratio of the Expenditure(as % of GDP) of St. Vincent and the Grenadines in 2007 to that in 2008?
Keep it short and to the point. 1.15. What is the ratio of the Expenditure(as % of GDP) of Aruba in 2007 to that in 2009?
Your answer should be compact. 0.55. What is the ratio of the Expenditure(as % of GDP) in Jordan in 2007 to that in 2009?
Your answer should be compact. 1.34. What is the ratio of the Expenditure(as % of GDP) in Macao in 2007 to that in 2009?
Ensure brevity in your answer.  1.33. What is the ratio of the Expenditure(as % of GDP) in St. Vincent and the Grenadines in 2007 to that in 2009?
Your answer should be very brief. 1.03. What is the ratio of the Expenditure(as % of GDP) in Aruba in 2007 to that in 2010?
Offer a terse response. 0.98. What is the ratio of the Expenditure(as % of GDP) of Jordan in 2007 to that in 2010?
Ensure brevity in your answer.  1.46. What is the ratio of the Expenditure(as % of GDP) of Macao in 2007 to that in 2010?
Offer a very short reply. 1.82. What is the ratio of the Expenditure(as % of GDP) in St. Vincent and the Grenadines in 2007 to that in 2010?
Your response must be concise. 1.04. What is the ratio of the Expenditure(as % of GDP) in Aruba in 2007 to that in 2011?
Offer a very short reply. 0.96. What is the ratio of the Expenditure(as % of GDP) in Jordan in 2007 to that in 2011?
Offer a terse response. 1.66. What is the ratio of the Expenditure(as % of GDP) in Macao in 2007 to that in 2011?
Your response must be concise. 2.29. What is the ratio of the Expenditure(as % of GDP) in St. Vincent and the Grenadines in 2007 to that in 2011?
Offer a terse response. 1.02. What is the ratio of the Expenditure(as % of GDP) of Aruba in 2008 to that in 2009?
Keep it short and to the point. 0.67. What is the ratio of the Expenditure(as % of GDP) in Jordan in 2008 to that in 2009?
Make the answer very short. 1.1. What is the ratio of the Expenditure(as % of GDP) in Macao in 2008 to that in 2009?
Give a very brief answer. 1.1. What is the ratio of the Expenditure(as % of GDP) of St. Vincent and the Grenadines in 2008 to that in 2009?
Offer a very short reply. 0.89. What is the ratio of the Expenditure(as % of GDP) in Aruba in 2008 to that in 2010?
Offer a very short reply. 1.2. What is the ratio of the Expenditure(as % of GDP) in Jordan in 2008 to that in 2010?
Provide a short and direct response. 1.2. What is the ratio of the Expenditure(as % of GDP) of Macao in 2008 to that in 2010?
Offer a terse response. 1.51. What is the ratio of the Expenditure(as % of GDP) in St. Vincent and the Grenadines in 2008 to that in 2010?
Provide a succinct answer. 0.9. What is the ratio of the Expenditure(as % of GDP) of Aruba in 2008 to that in 2011?
Offer a terse response. 1.18. What is the ratio of the Expenditure(as % of GDP) in Jordan in 2008 to that in 2011?
Make the answer very short. 1.37. What is the ratio of the Expenditure(as % of GDP) of Macao in 2008 to that in 2011?
Provide a succinct answer. 1.89. What is the ratio of the Expenditure(as % of GDP) of St. Vincent and the Grenadines in 2008 to that in 2011?
Your answer should be very brief. 0.89. What is the ratio of the Expenditure(as % of GDP) of Aruba in 2009 to that in 2010?
Provide a short and direct response. 1.8. What is the ratio of the Expenditure(as % of GDP) in Jordan in 2009 to that in 2010?
Your response must be concise. 1.09. What is the ratio of the Expenditure(as % of GDP) in Macao in 2009 to that in 2010?
Your response must be concise. 1.37. What is the ratio of the Expenditure(as % of GDP) in St. Vincent and the Grenadines in 2009 to that in 2010?
Your response must be concise. 1.01. What is the ratio of the Expenditure(as % of GDP) in Aruba in 2009 to that in 2011?
Your answer should be very brief. 1.76. What is the ratio of the Expenditure(as % of GDP) of Jordan in 2009 to that in 2011?
Make the answer very short. 1.25. What is the ratio of the Expenditure(as % of GDP) in Macao in 2009 to that in 2011?
Offer a terse response. 1.72. What is the ratio of the Expenditure(as % of GDP) of Aruba in 2010 to that in 2011?
Your response must be concise. 0.98. What is the ratio of the Expenditure(as % of GDP) of Jordan in 2010 to that in 2011?
Your answer should be very brief. 1.14. What is the ratio of the Expenditure(as % of GDP) of Macao in 2010 to that in 2011?
Offer a very short reply. 1.25. What is the ratio of the Expenditure(as % of GDP) in St. Vincent and the Grenadines in 2010 to that in 2011?
Your response must be concise. 0.99. What is the difference between the highest and the second highest Expenditure(as % of GDP) in Aruba?
Your answer should be compact. 0.12. What is the difference between the highest and the second highest Expenditure(as % of GDP) in Jordan?
Your answer should be very brief. 0.21. What is the difference between the highest and the second highest Expenditure(as % of GDP) of Macao?
Your response must be concise. 0.07. What is the difference between the highest and the second highest Expenditure(as % of GDP) in St. Vincent and the Grenadines?
Provide a succinct answer. 0.11. What is the difference between the highest and the lowest Expenditure(as % of GDP) in Aruba?
Your answer should be compact. 0.33. What is the difference between the highest and the lowest Expenditure(as % of GDP) of Jordan?
Keep it short and to the point. 7.76. What is the difference between the highest and the lowest Expenditure(as % of GDP) in Macao?
Offer a very short reply. 0.32. What is the difference between the highest and the lowest Expenditure(as % of GDP) in St. Vincent and the Grenadines?
Offer a very short reply. 0.58. 